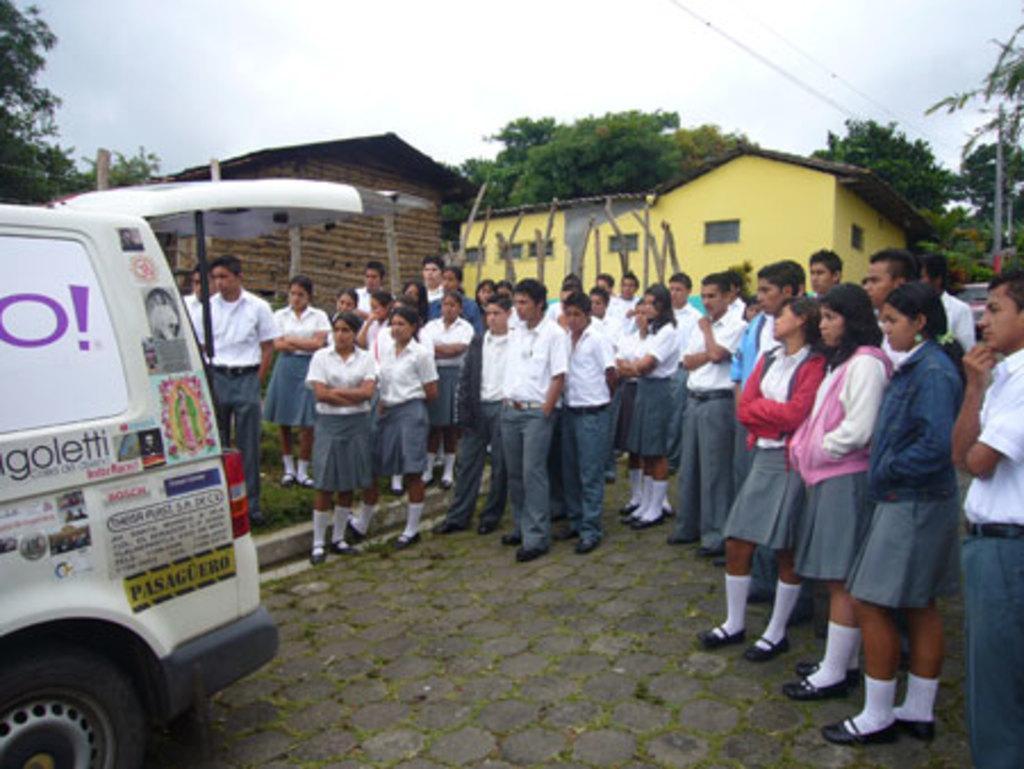Can you describe this image briefly? In this picture I can see many peoples were standing on the street. On the left there is a white color van. On the van I can see many stickers and posters were attached. In the back I can see the shed and building. In the background I can see many trees. On the right I can see electric poles and wires are connected to it. At the top I can see the sky and clouds. 